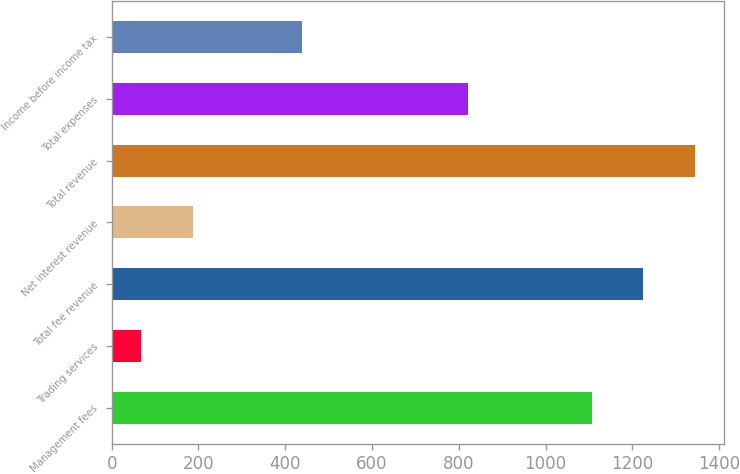Convert chart. <chart><loc_0><loc_0><loc_500><loc_500><bar_chart><fcel>Management fees<fcel>Trading services<fcel>Total fee revenue<fcel>Net interest revenue<fcel>Total revenue<fcel>Total expenses<fcel>Income before income tax<nl><fcel>1106<fcel>67<fcel>1225.4<fcel>186.4<fcel>1344.8<fcel>822<fcel>439<nl></chart> 